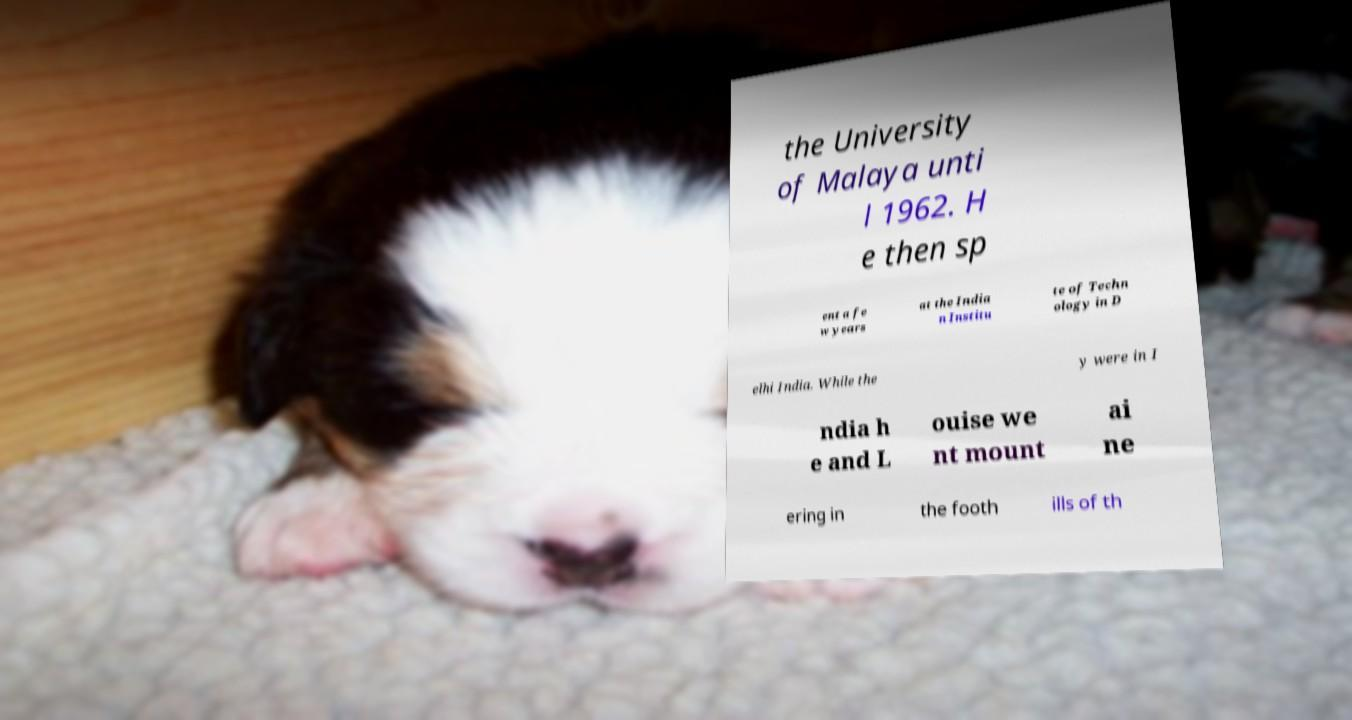Can you read and provide the text displayed in the image?This photo seems to have some interesting text. Can you extract and type it out for me? the University of Malaya unti l 1962. H e then sp ent a fe w years at the India n Institu te of Techn ology in D elhi India. While the y were in I ndia h e and L ouise we nt mount ai ne ering in the footh ills of th 